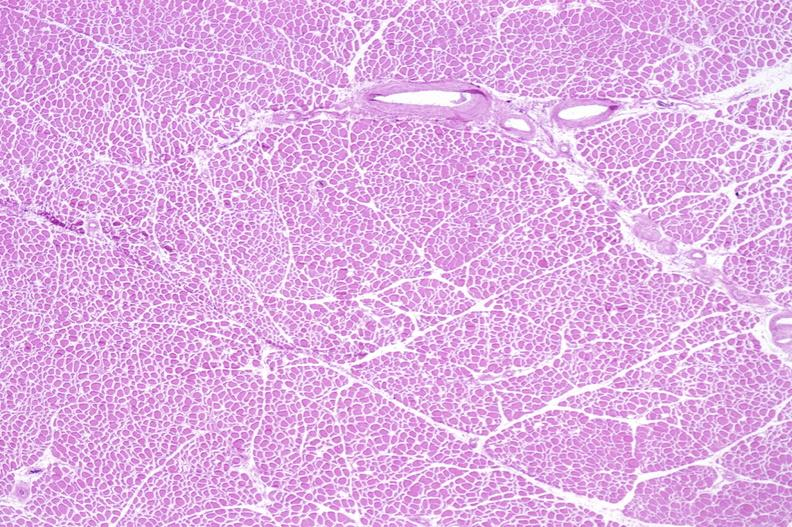does this image show skeletal muscle atrophy?
Answer the question using a single word or phrase. Yes 